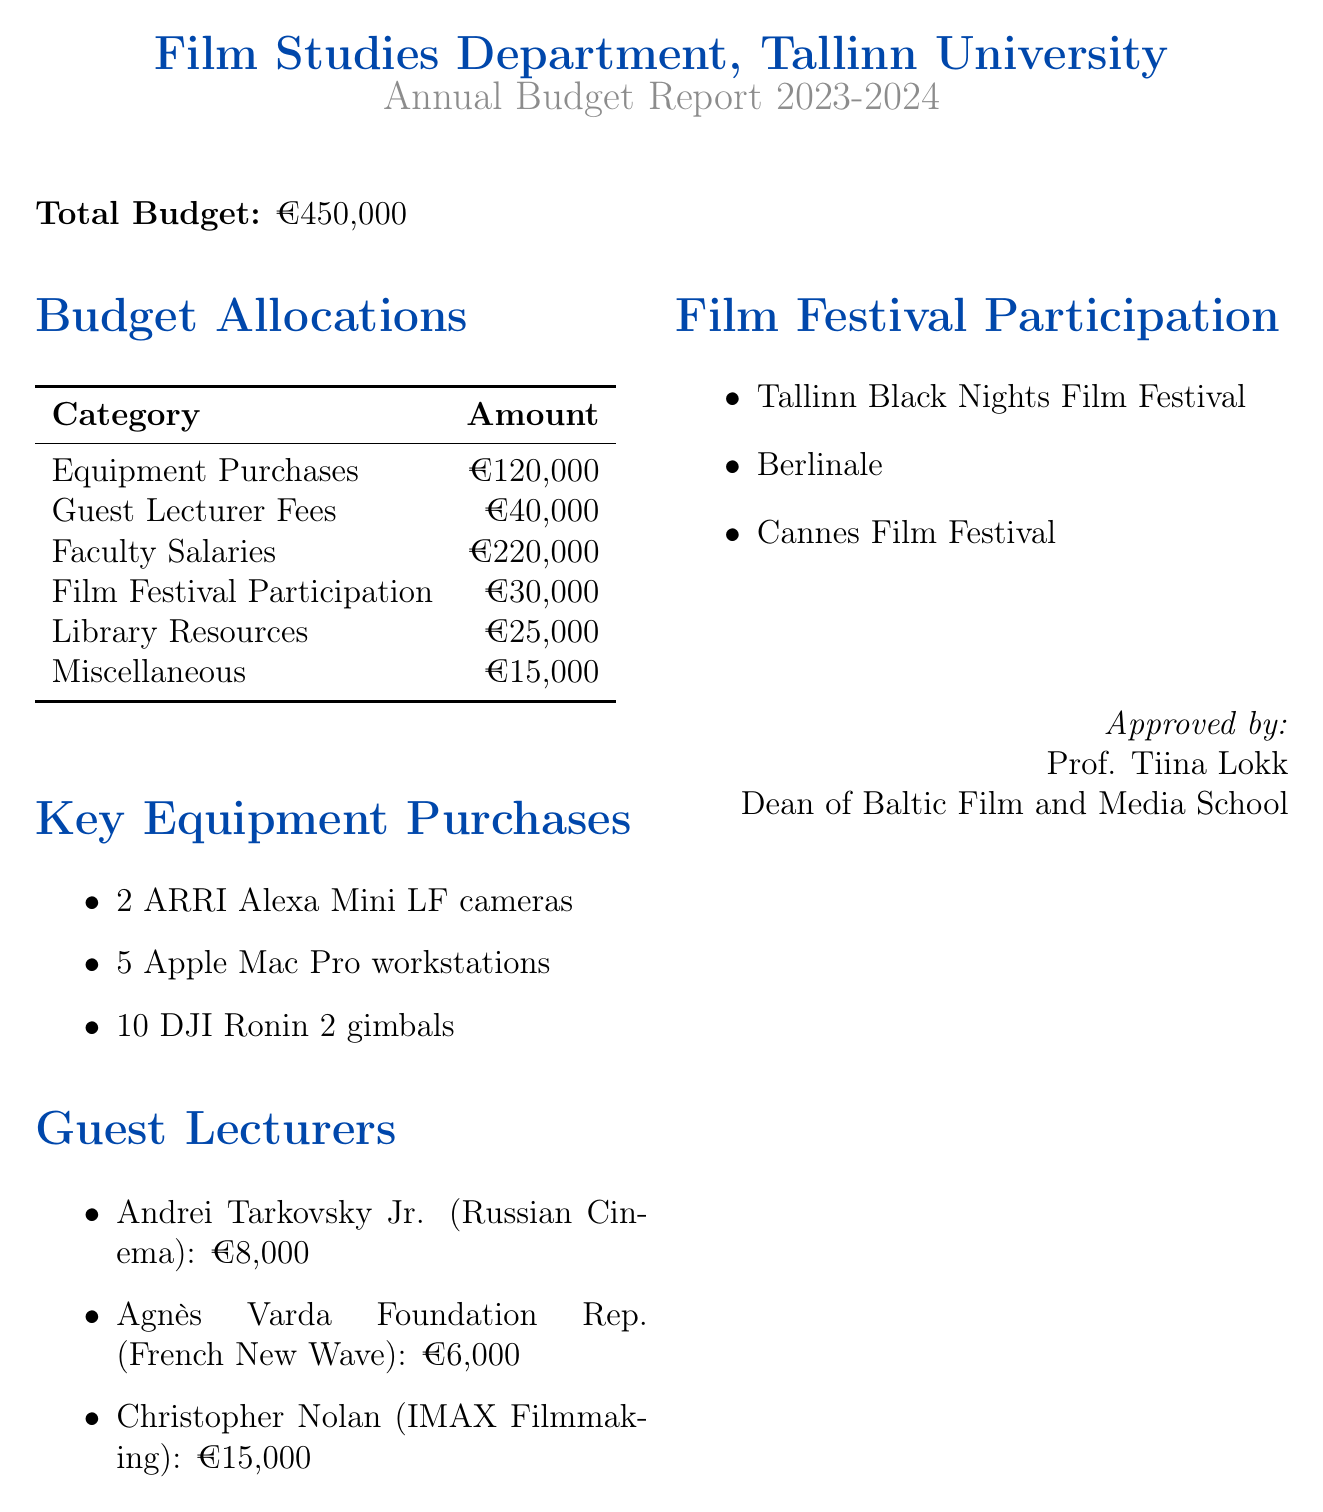What is the total budget for the Film Studies Department? The total budget is explicitly stated in the document as €450,000.
Answer: €450,000 How much is allocated for Equipment Purchases? The allocation for Equipment Purchases is listed as €120,000 in the budget categories.
Answer: €120,000 Who is the guest lecturer specializing in Russian Cinema? The document lists Andrei Tarkovsky Jr. as the guest lecturer for Russian Cinema.
Answer: Andrei Tarkovsky Jr What is the fee for Christopher Nolan? The document specifies Christopher Nolan's fee as €15,000 under the Guest Lecturer Fees category.
Answer: €15,000 How many film festivals are mentioned for participation? The document lists three film festivals under Film Festival Participation.
Answer: Three What is the total allocation for Faculty Salaries? The budget report indicates the Faculty Salaries allocation is €220,000.
Answer: €220,000 What is the amount allocated for Library Resources? The Library Resources allocation is expressly stated as €25,000 in the budget.
Answer: €25,000 Who approved the budget report? The document identifies Prof. Tiina Lokk as the approver of the budget report.
Answer: Prof. Tiina Lokk What specialized equipment is set to be purchased besides cameras? The document includes Apple Mac Pro workstations as equipment planned for purchase.
Answer: Apple Mac Pro workstations How much is budgeted for Guest Lecturer Fees? The total allocation for Guest Lecturer Fees is mentioned as €40,000.
Answer: €40,000 